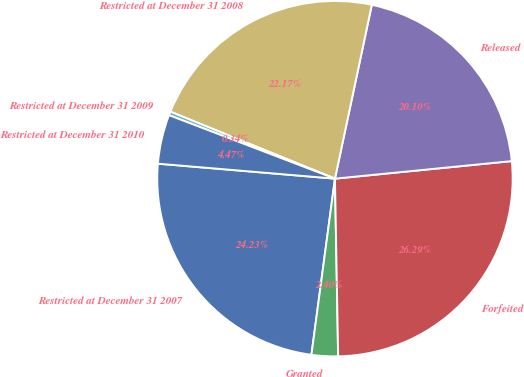Convert chart to OTSL. <chart><loc_0><loc_0><loc_500><loc_500><pie_chart><fcel>Restricted at December 31 2007<fcel>Granted<fcel>Forfeited<fcel>Released<fcel>Restricted at December 31 2008<fcel>Restricted at December 31 2009<fcel>Restricted at December 31 2010<nl><fcel>24.23%<fcel>2.4%<fcel>26.29%<fcel>20.1%<fcel>22.17%<fcel>0.34%<fcel>4.47%<nl></chart> 